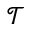<formula> <loc_0><loc_0><loc_500><loc_500>\mathcal { T }</formula> 